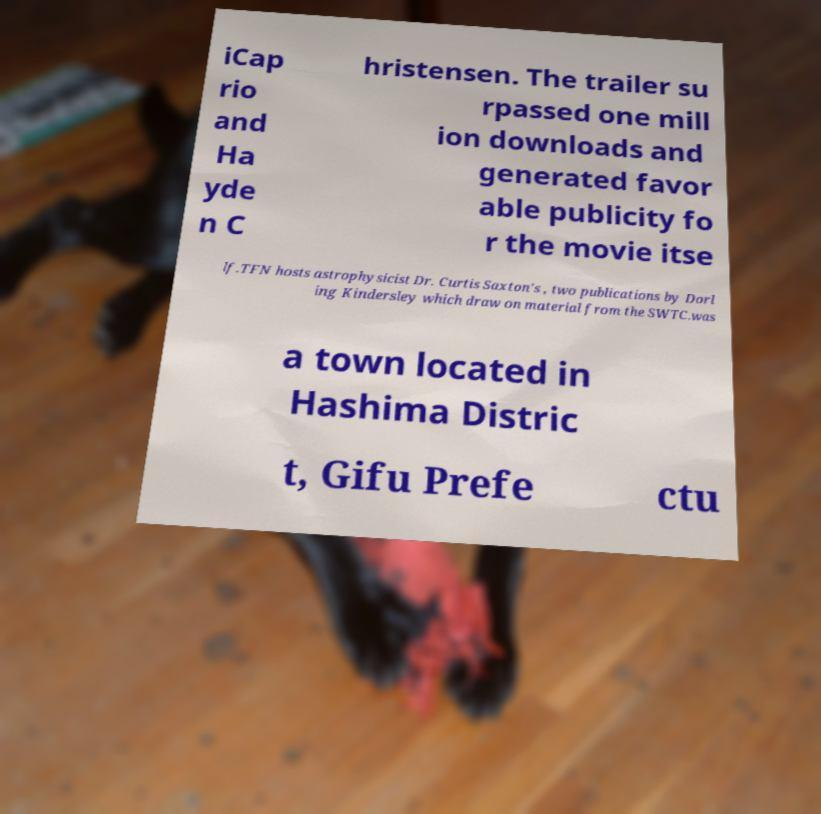For documentation purposes, I need the text within this image transcribed. Could you provide that? iCap rio and Ha yde n C hristensen. The trailer su rpassed one mill ion downloads and generated favor able publicity fo r the movie itse lf.TFN hosts astrophysicist Dr. Curtis Saxton's , two publications by Dorl ing Kindersley which draw on material from the SWTC.was a town located in Hashima Distric t, Gifu Prefe ctu 